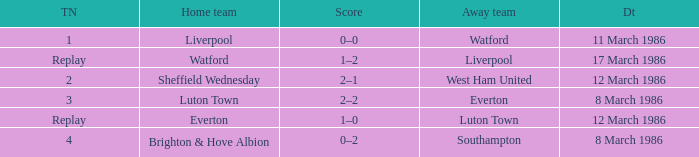What was the tied score in the game involving sheffield wednesday? 2.0. 